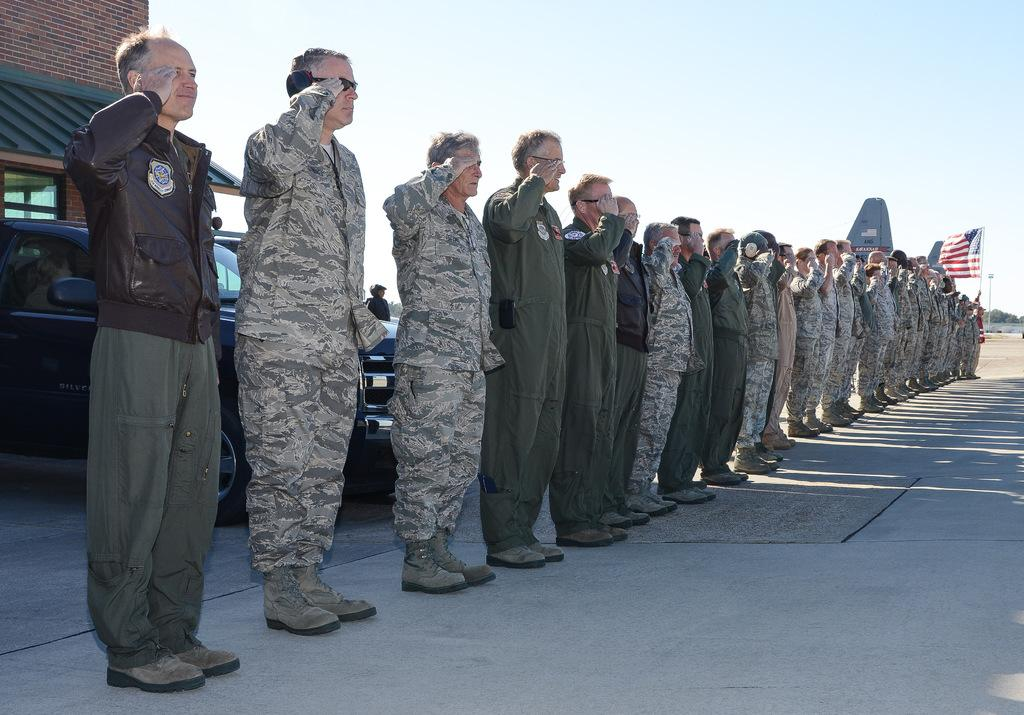What is the main subject of the image? The main subject of the image is a group of men. What are the men doing in the image? The men are shouting in the image. What can be seen on the right side of the image? There is a flag on the right side of the image. What is located on the left side of the image? There is a car and a building on the left side of the image. What is visible at the top of the image? The sky is visible at the top of the image. What type of curtain is hanging from the rod in the image? There is no curtain or rod present in the image. What suggestion can be made to improve the men's shouting technique in the image? The image does not provide enough information to make a suggestion about the men's shouting technique. 